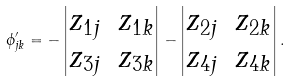<formula> <loc_0><loc_0><loc_500><loc_500>\phi ^ { \prime } _ { j k } = - \begin{vmatrix} z _ { 1 j } & z _ { 1 k } \\ z _ { 3 j } & z _ { 3 k } \end{vmatrix} - \begin{vmatrix} z _ { 2 j } & z _ { 2 k } \\ z _ { 4 j } & z _ { 4 k } \end{vmatrix} .</formula> 